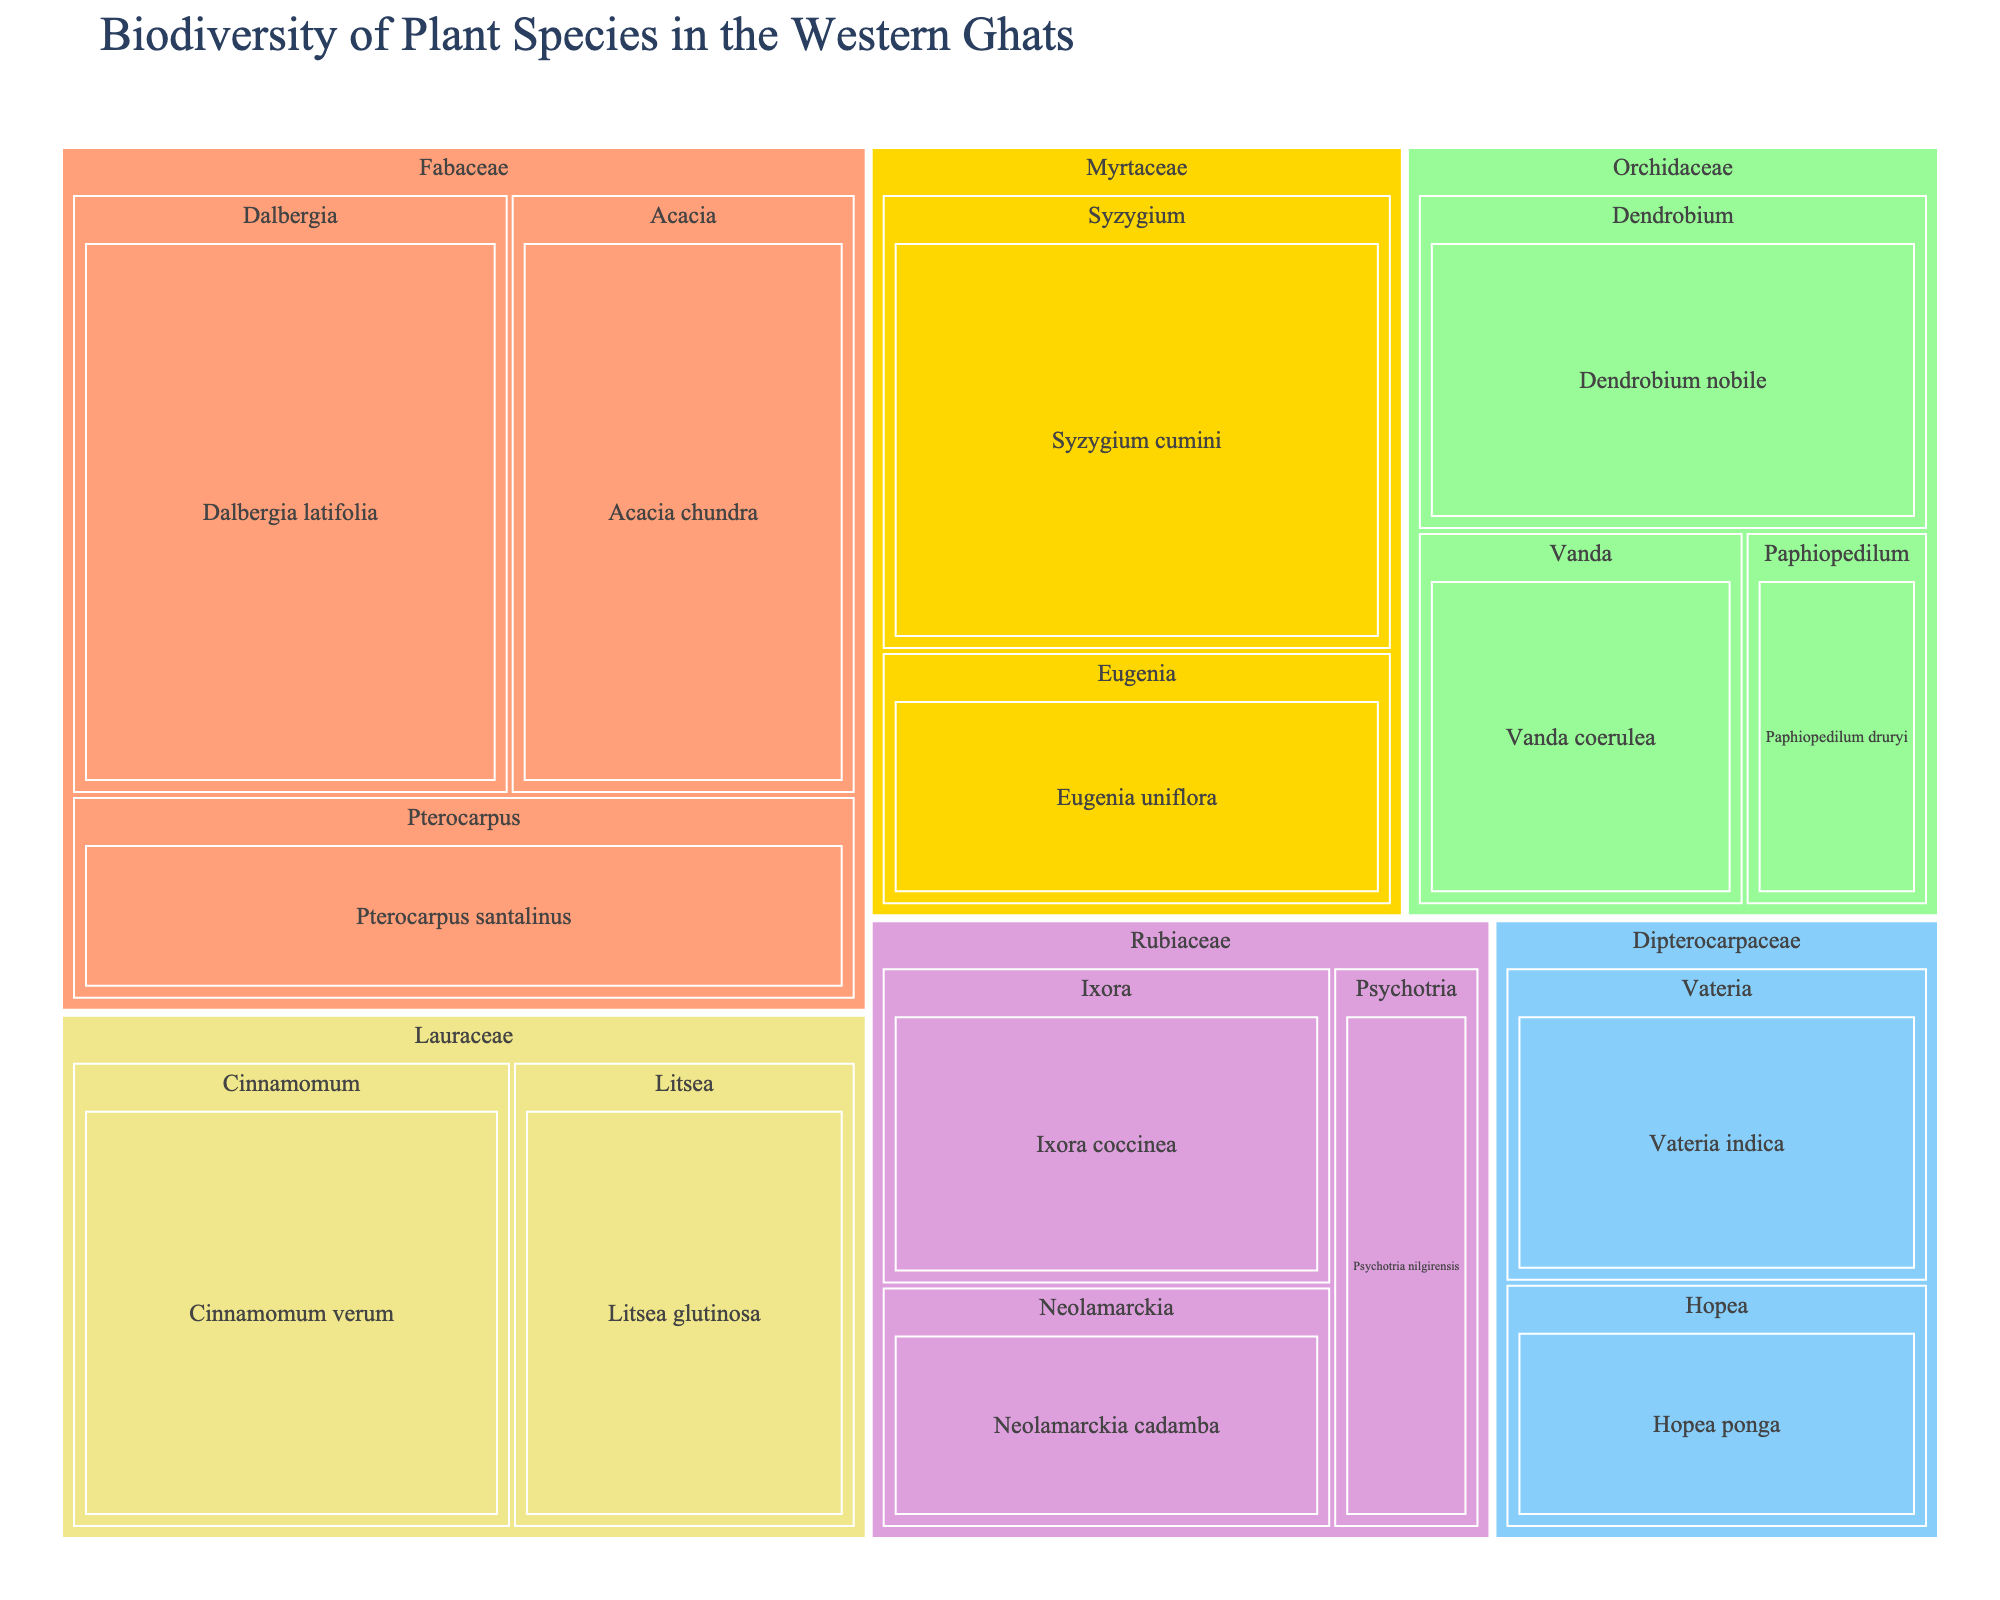Which plant family has the highest count of species? The treemap shows different plant families with their respective counts. By comparing all the families, Fabaceae has the highest species count when compared individually.
Answer: Fabaceae How many species are there within the Orchidaceae family? The Orchidaceae family has three genera: Dendrobium, Vanda, and Paphiopedilum. Summing their counts (45, 32, and 18), we get 95.
Answer: 95 Which genus within the Fabaceae family has the highest count, and what is that count? The genera within the Fabaceae family are Dalbergia, Pterocarpus, and Acacia. Dalbergia has 67, Pterocarpus has 41, and Acacia has 53. Dalbergia has the highest count.
Answer: Dalbergia with 67 Comparing Lauraceae and Myrtaceae families, which one has a higher total species count? Lauraceae has Cinnamomum (55) and Litsea (43), which totals 98. Myrtaceae has Syzygium (61) and Eugenia (34), totaling 95. Therefore, Lauraceae has a higher species count.
Answer: Lauraceae What is the sum of species counts for all genera within the Rubiaceae family? The Rubiaceae family includes the genera Neolamarckia (29), Ixora (38), and Psychotria (22). Adding these counts gives 89.
Answer: 89 Which species has the highest individual count and what is that count? Reviewing all species within the treemap, Dalbergia latifolia has the highest count, which is 67.
Answer: Dalbergia latifolia with 67 How does the count of Syzygium cumini compare to Eugenia uniflora? Syzygium cumini has a count of 61 while Eugenia uniflora has 34. Syzygium cumini has a higher count than Eugenia uniflora.
Answer: Syzygium cumini is higher How many different families are represented in the treemap? Each distinct color in the treemap represents a different family. By counting the colors or the family labels, we find there are six families represented.
Answer: 6 Which genus in the Dipterocarpaceae family has fewer species: Vateria or Hopea? In Dipterocarpaceae, Vateria has 36 species and Hopea has 28. Thus, Hopea has fewer species.
Answer: Hopea What is the average count of species per genus under the Myrtaceae family? The Myrtaceae family has the genera Syzygium (61) and Eugenia (34). The average count is calculated as (61 + 34) / 2 = 47.5.
Answer: 47.5 